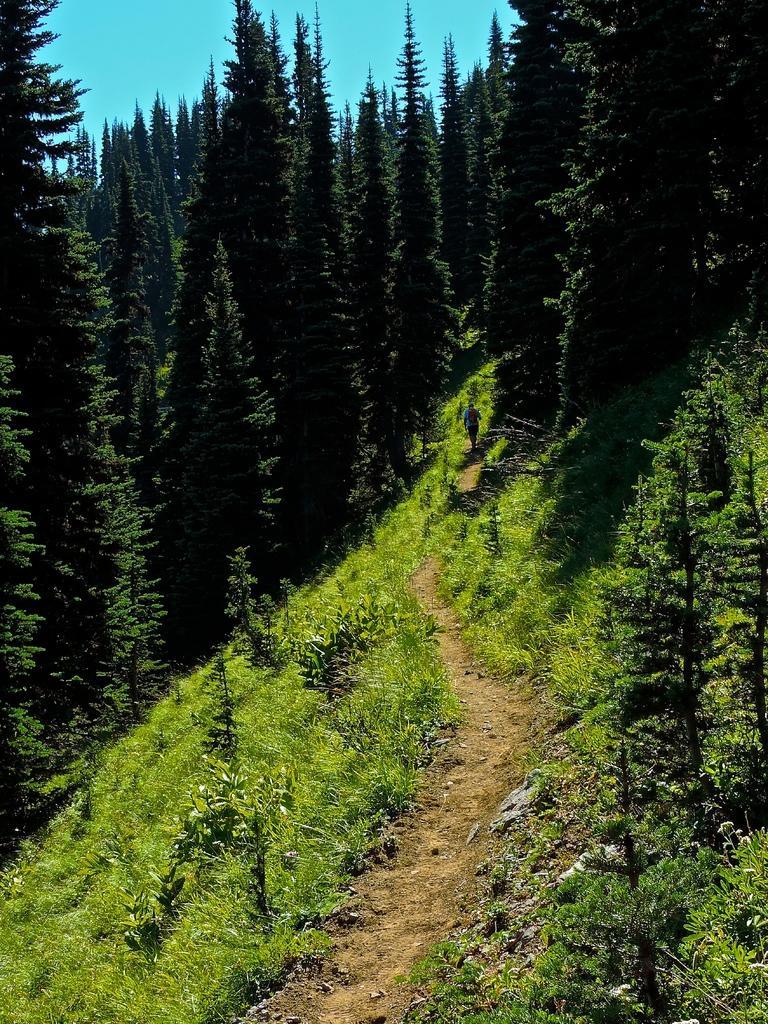Describe this image in one or two sentences. In this image, we can see some trees and plants. There is a sky at the top of the image. 